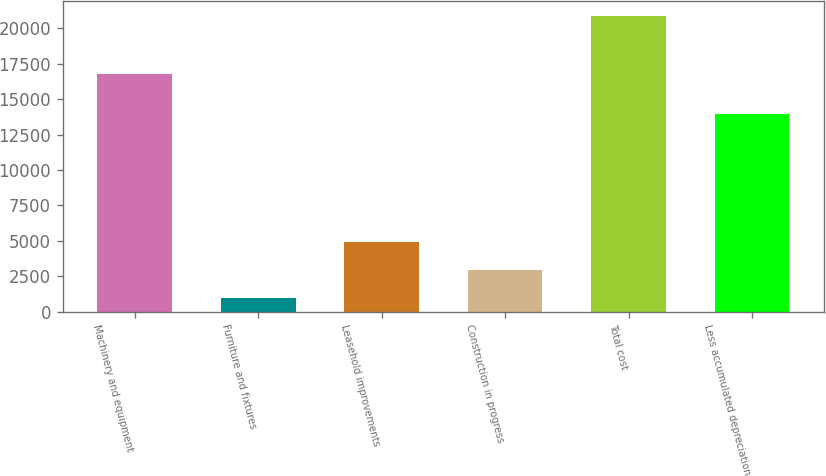Convert chart to OTSL. <chart><loc_0><loc_0><loc_500><loc_500><bar_chart><fcel>Machinery and equipment<fcel>Furniture and fixtures<fcel>Leasehold improvements<fcel>Construction in progress<fcel>Total cost<fcel>Less accumulated depreciation<nl><fcel>16805<fcel>960<fcel>4941.4<fcel>2950.7<fcel>20867<fcel>13978<nl></chart> 